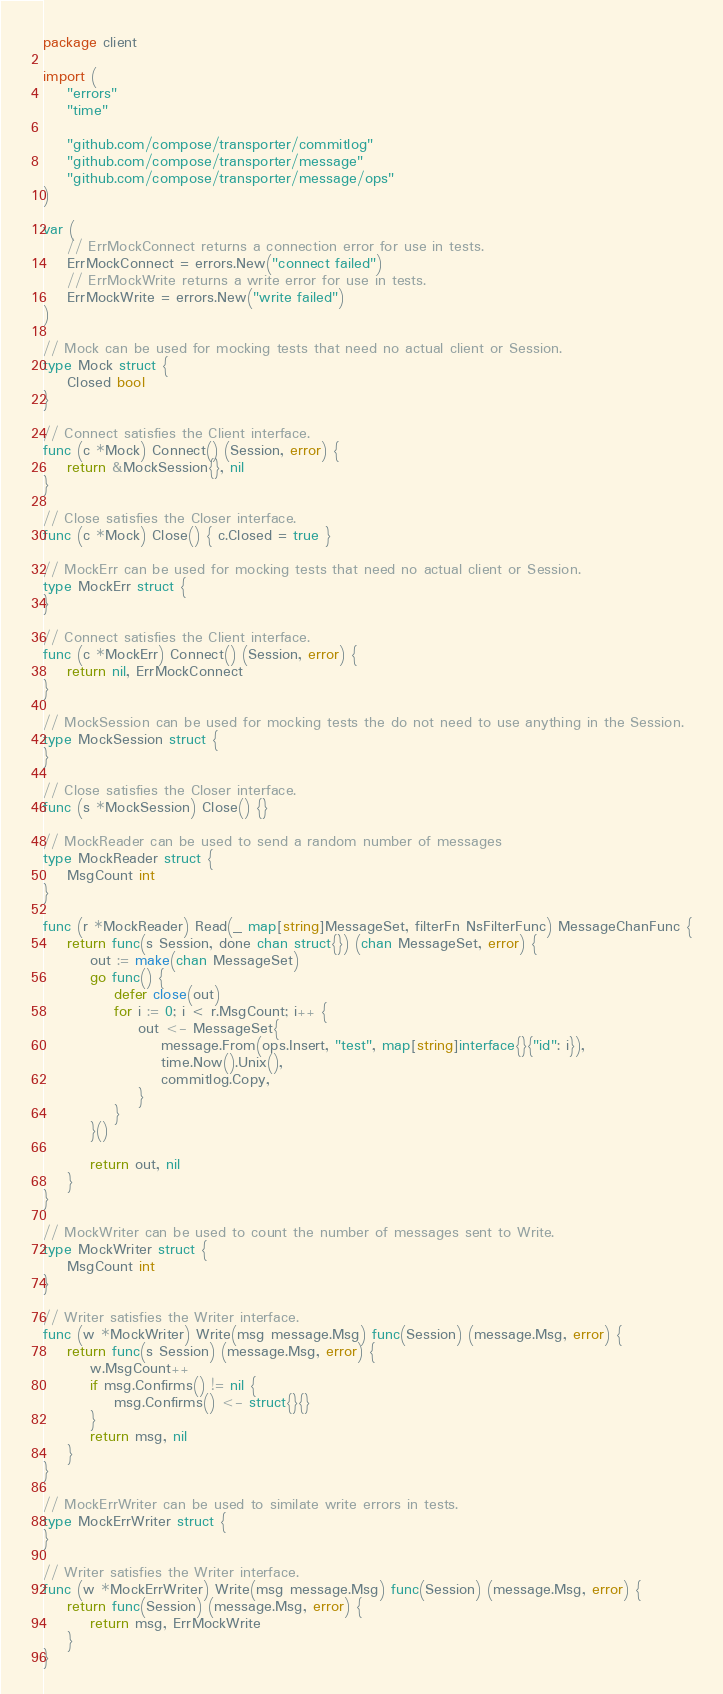Convert code to text. <code><loc_0><loc_0><loc_500><loc_500><_Go_>package client

import (
	"errors"
	"time"

	"github.com/compose/transporter/commitlog"
	"github.com/compose/transporter/message"
	"github.com/compose/transporter/message/ops"
)

var (
	// ErrMockConnect returns a connection error for use in tests.
	ErrMockConnect = errors.New("connect failed")
	// ErrMockWrite returns a write error for use in tests.
	ErrMockWrite = errors.New("write failed")
)

// Mock can be used for mocking tests that need no actual client or Session.
type Mock struct {
	Closed bool
}

// Connect satisfies the Client interface.
func (c *Mock) Connect() (Session, error) {
	return &MockSession{}, nil
}

// Close satisfies the Closer interface.
func (c *Mock) Close() { c.Closed = true }

// MockErr can be used for mocking tests that need no actual client or Session.
type MockErr struct {
}

// Connect satisfies the Client interface.
func (c *MockErr) Connect() (Session, error) {
	return nil, ErrMockConnect
}

// MockSession can be used for mocking tests the do not need to use anything in the Session.
type MockSession struct {
}

// Close satisfies the Closer interface.
func (s *MockSession) Close() {}

// MockReader can be used to send a random number of messages
type MockReader struct {
	MsgCount int
}

func (r *MockReader) Read(_ map[string]MessageSet, filterFn NsFilterFunc) MessageChanFunc {
	return func(s Session, done chan struct{}) (chan MessageSet, error) {
		out := make(chan MessageSet)
		go func() {
			defer close(out)
			for i := 0; i < r.MsgCount; i++ {
				out <- MessageSet{
					message.From(ops.Insert, "test", map[string]interface{}{"id": i}),
					time.Now().Unix(),
					commitlog.Copy,
				}
			}
		}()

		return out, nil
	}
}

// MockWriter can be used to count the number of messages sent to Write.
type MockWriter struct {
	MsgCount int
}

// Writer satisfies the Writer interface.
func (w *MockWriter) Write(msg message.Msg) func(Session) (message.Msg, error) {
	return func(s Session) (message.Msg, error) {
		w.MsgCount++
		if msg.Confirms() != nil {
			msg.Confirms() <- struct{}{}
		}
		return msg, nil
	}
}

// MockErrWriter can be used to similate write errors in tests.
type MockErrWriter struct {
}

// Writer satisfies the Writer interface.
func (w *MockErrWriter) Write(msg message.Msg) func(Session) (message.Msg, error) {
	return func(Session) (message.Msg, error) {
		return msg, ErrMockWrite
	}
}
</code> 